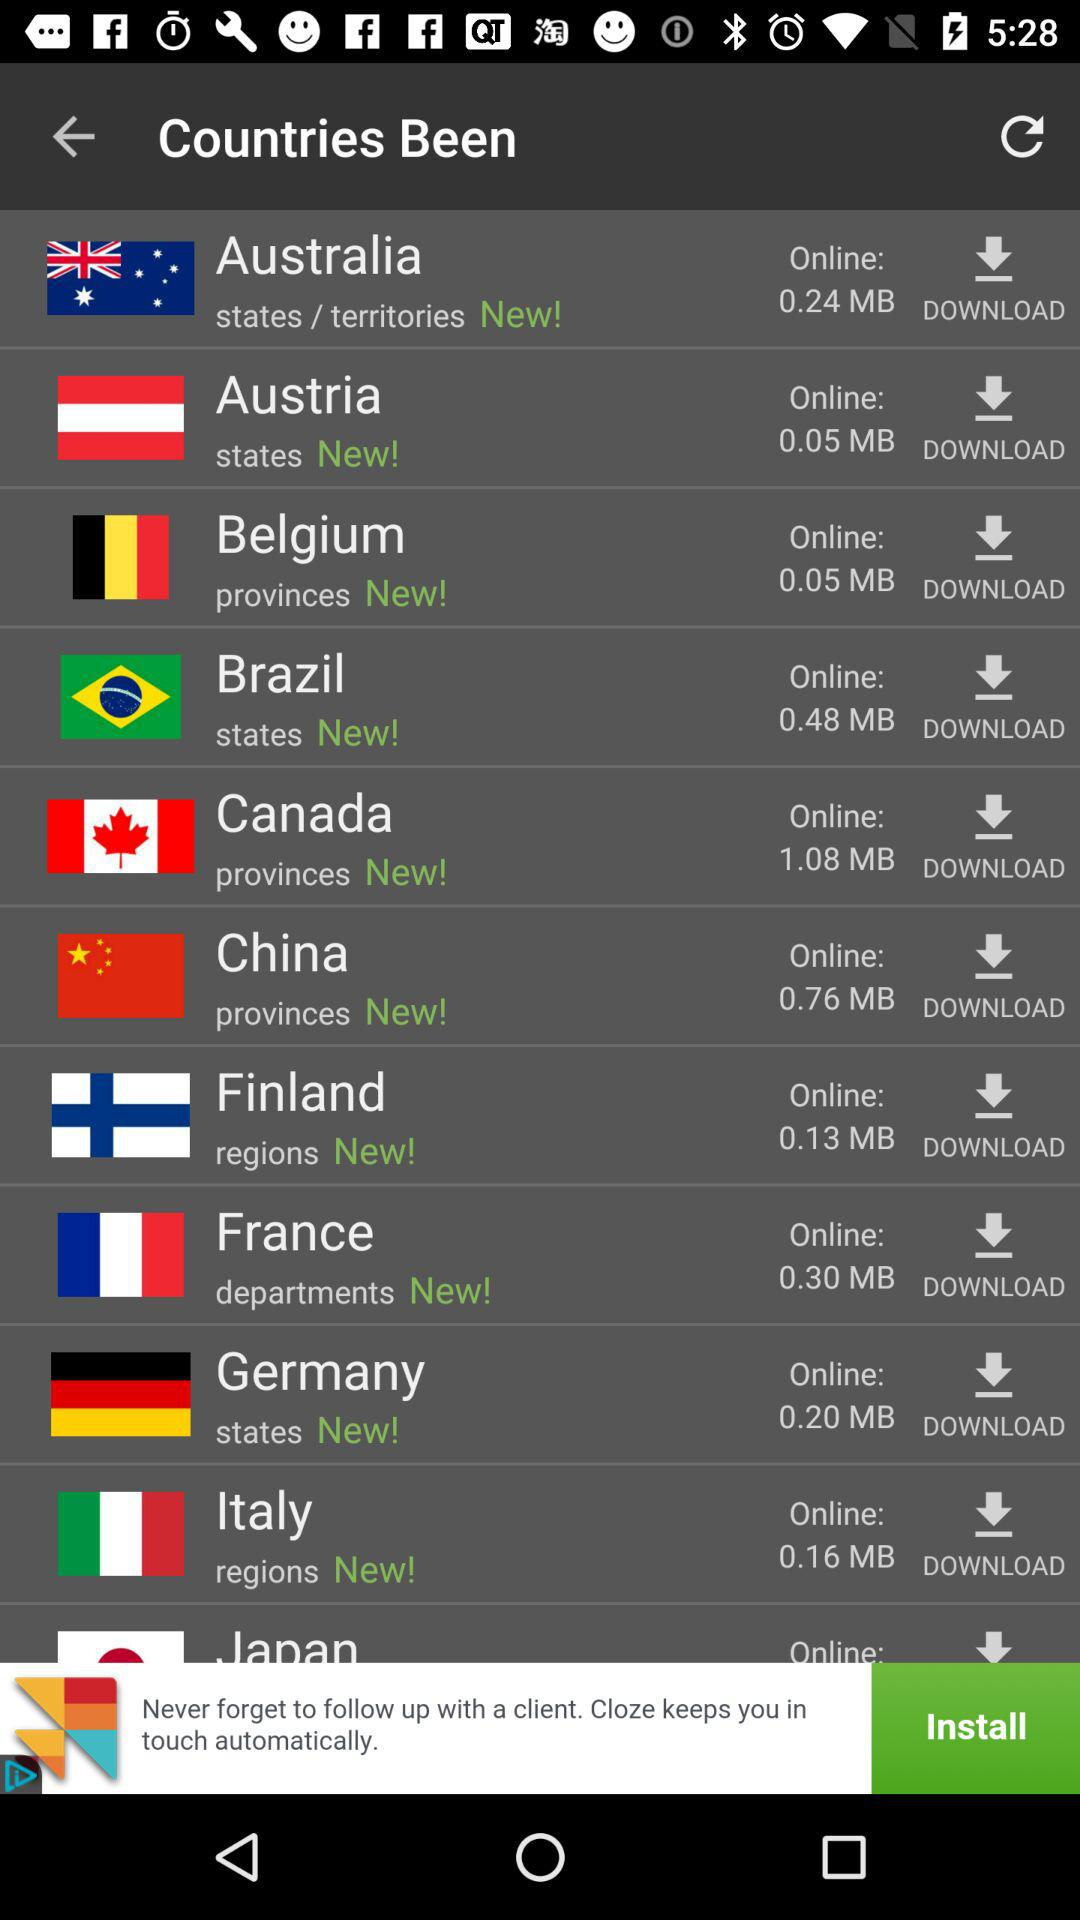What is the size mentioned for Finland? The mentioned size is 0.13 MB. 